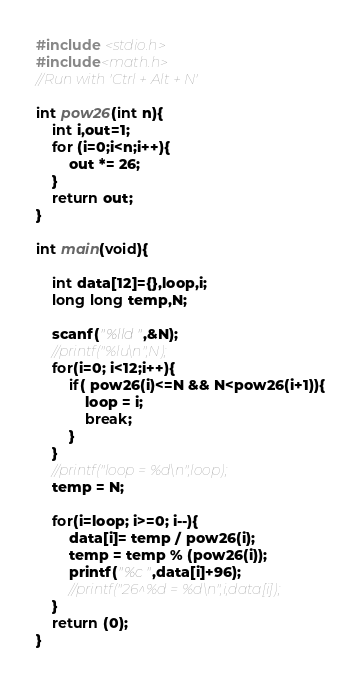Convert code to text. <code><loc_0><loc_0><loc_500><loc_500><_C_>#include <stdio.h>
#include<math.h>
//Run with 'Ctrl + Alt + N'

int pow26(int n){
    int i,out=1;
    for (i=0;i<n;i++){
        out *= 26;
    }
    return out;
}

int main(void){

    int data[12]={},loop,i;
    long long temp,N;
    
    scanf("%lld",&N);
    //printf("%lu\n",N);
    for(i=0; i<12;i++){
        if( pow26(i)<=N && N<pow26(i+1)){
            loop = i;
            break;
        }
    }
    //printf("loop = %d\n",loop);
    temp = N;

    for(i=loop; i>=0; i--){
        data[i]= temp / pow26(i);
        temp = temp % (pow26(i));
        printf("%c",data[i]+96);
        //printf("26^%d = %d\n",i,data[i]);
    }
    return (0);
}</code> 